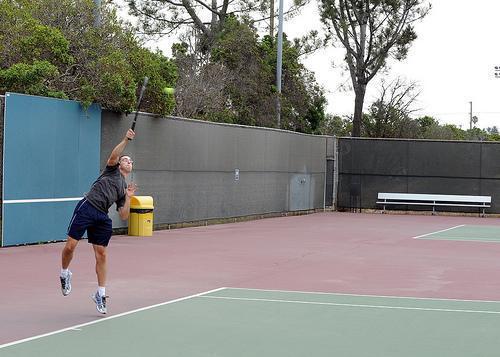How many people are there?
Give a very brief answer. 1. 